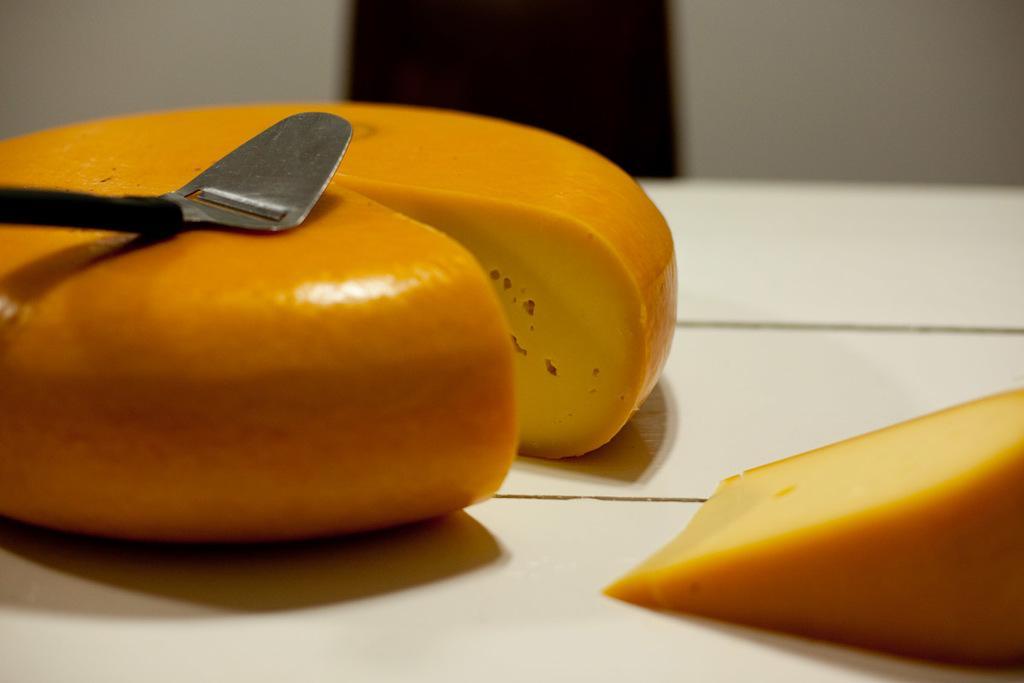Describe this image in one or two sentences. In this image there is a food item with spoon on table in the foreground. And there is door, wall in the background. 